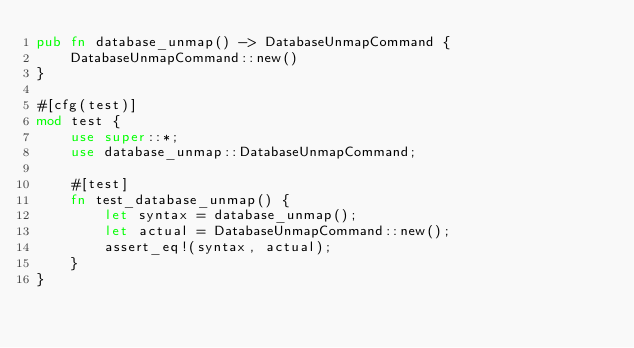Convert code to text. <code><loc_0><loc_0><loc_500><loc_500><_Rust_>pub fn database_unmap() -> DatabaseUnmapCommand {
    DatabaseUnmapCommand::new()
}

#[cfg(test)]
mod test {
    use super::*;
    use database_unmap::DatabaseUnmapCommand;

    #[test]
    fn test_database_unmap() {
        let syntax = database_unmap();
        let actual = DatabaseUnmapCommand::new();
        assert_eq!(syntax, actual);
    }
}
</code> 